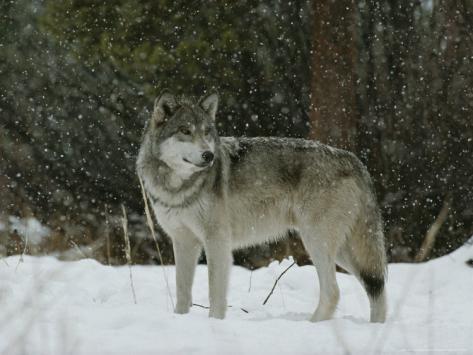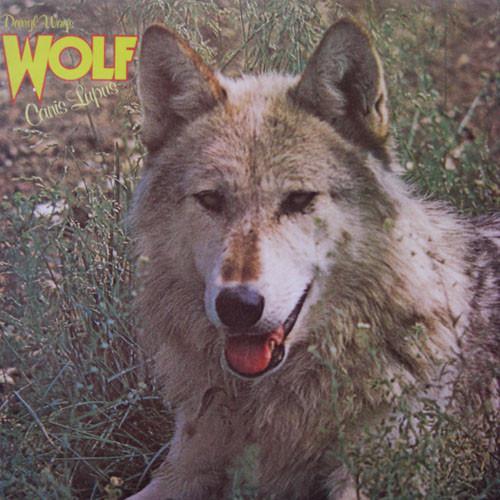The first image is the image on the left, the second image is the image on the right. Examine the images to the left and right. Is the description "Each image contains a single wolf, and the left image features a wolf reclining on the snow with its body angled rightward." accurate? Answer yes or no. No. The first image is the image on the left, the second image is the image on the right. Considering the images on both sides, is "In each image the terrain around the wolf is covered in snow." valid? Answer yes or no. No. 